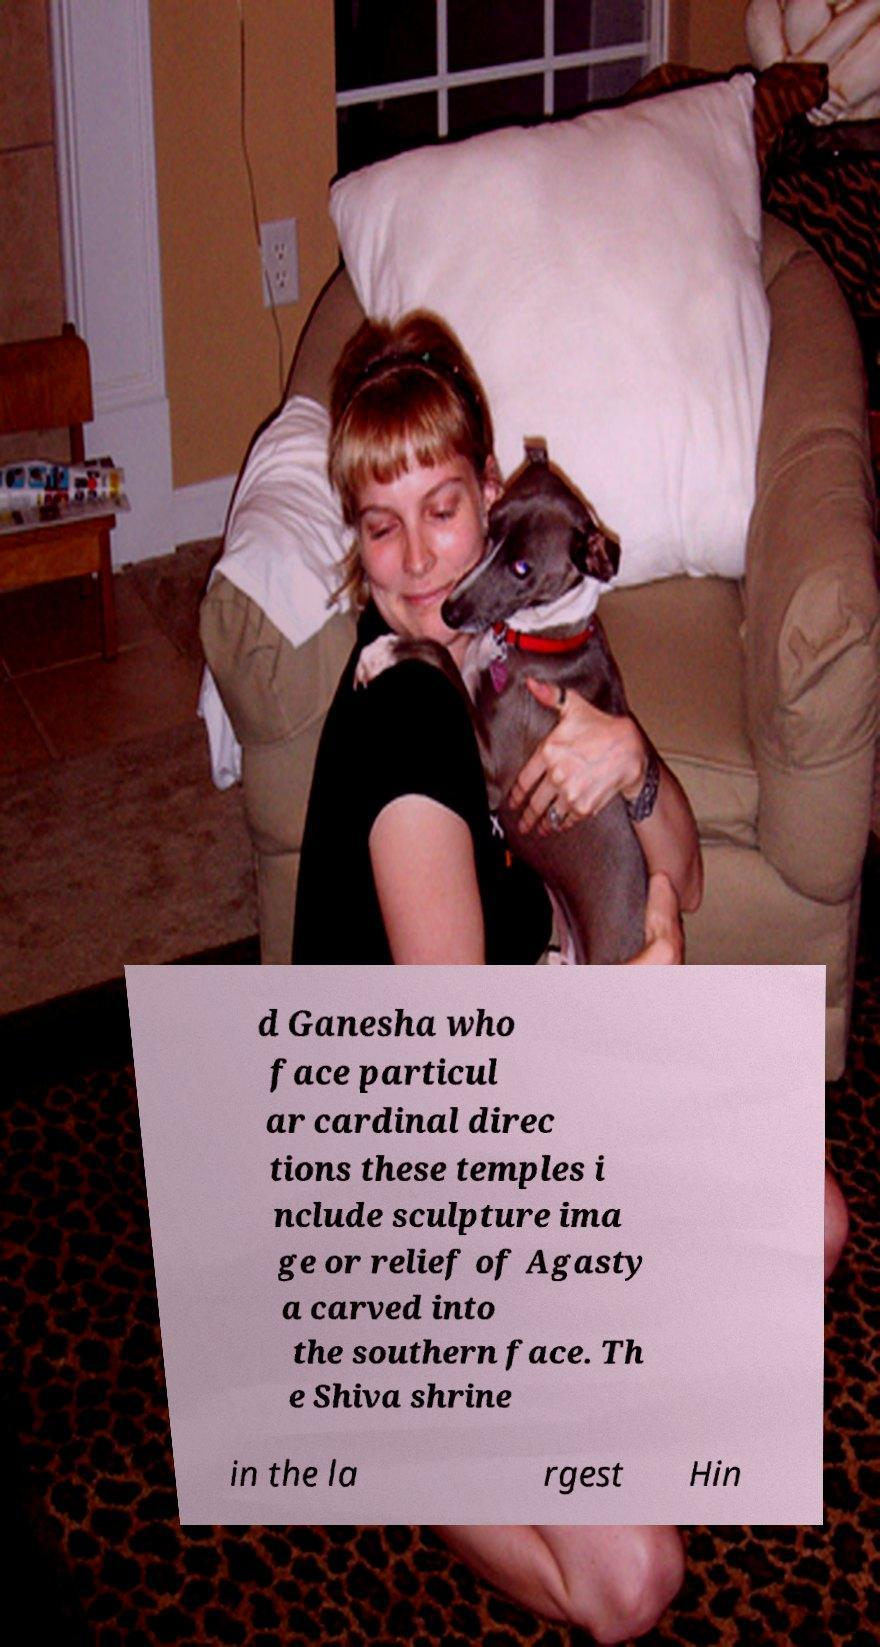I need the written content from this picture converted into text. Can you do that? d Ganesha who face particul ar cardinal direc tions these temples i nclude sculpture ima ge or relief of Agasty a carved into the southern face. Th e Shiva shrine in the la rgest Hin 